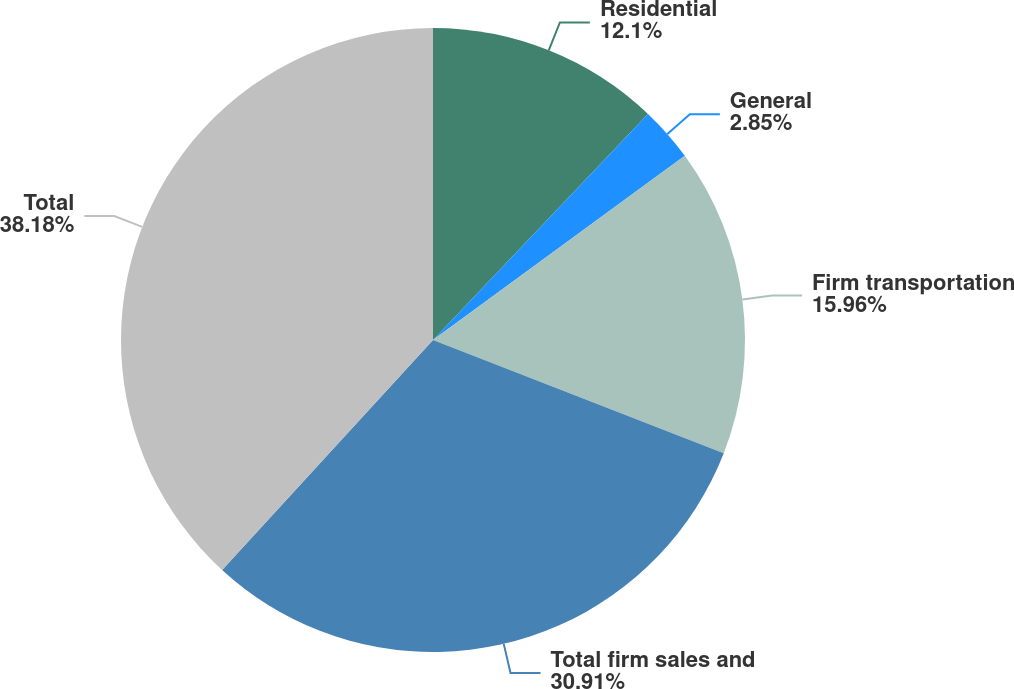Convert chart. <chart><loc_0><loc_0><loc_500><loc_500><pie_chart><fcel>Residential<fcel>General<fcel>Firm transportation<fcel>Total firm sales and<fcel>Total<nl><fcel>12.1%<fcel>2.85%<fcel>15.96%<fcel>30.91%<fcel>38.19%<nl></chart> 